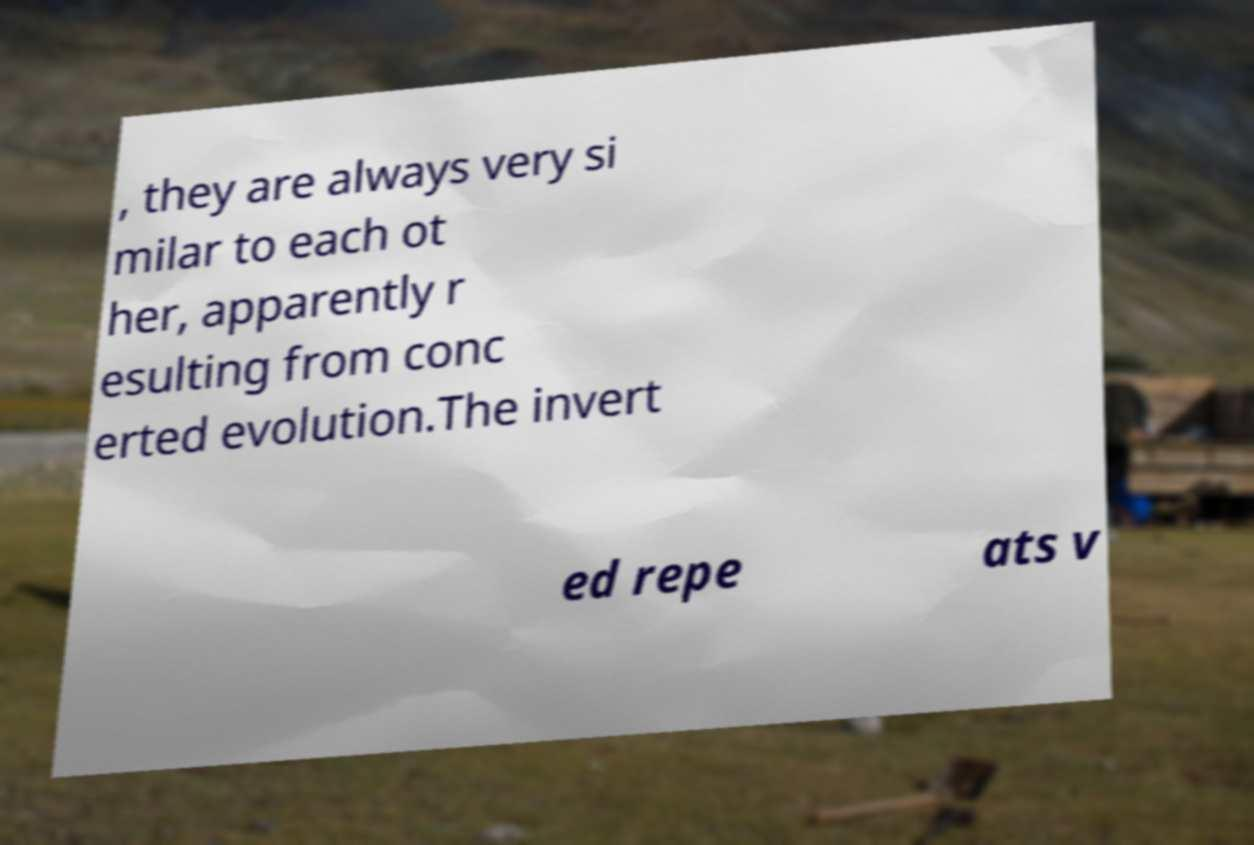There's text embedded in this image that I need extracted. Can you transcribe it verbatim? , they are always very si milar to each ot her, apparently r esulting from conc erted evolution.The invert ed repe ats v 